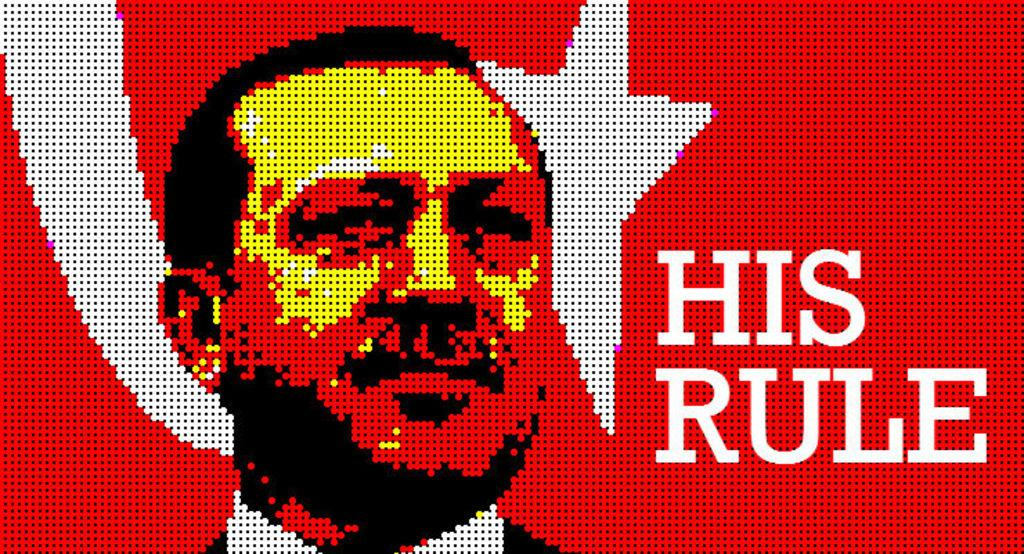<image>
Relay a brief, clear account of the picture shown. A man is drawn in front of a flag and the words "his rule" are written beside him. 